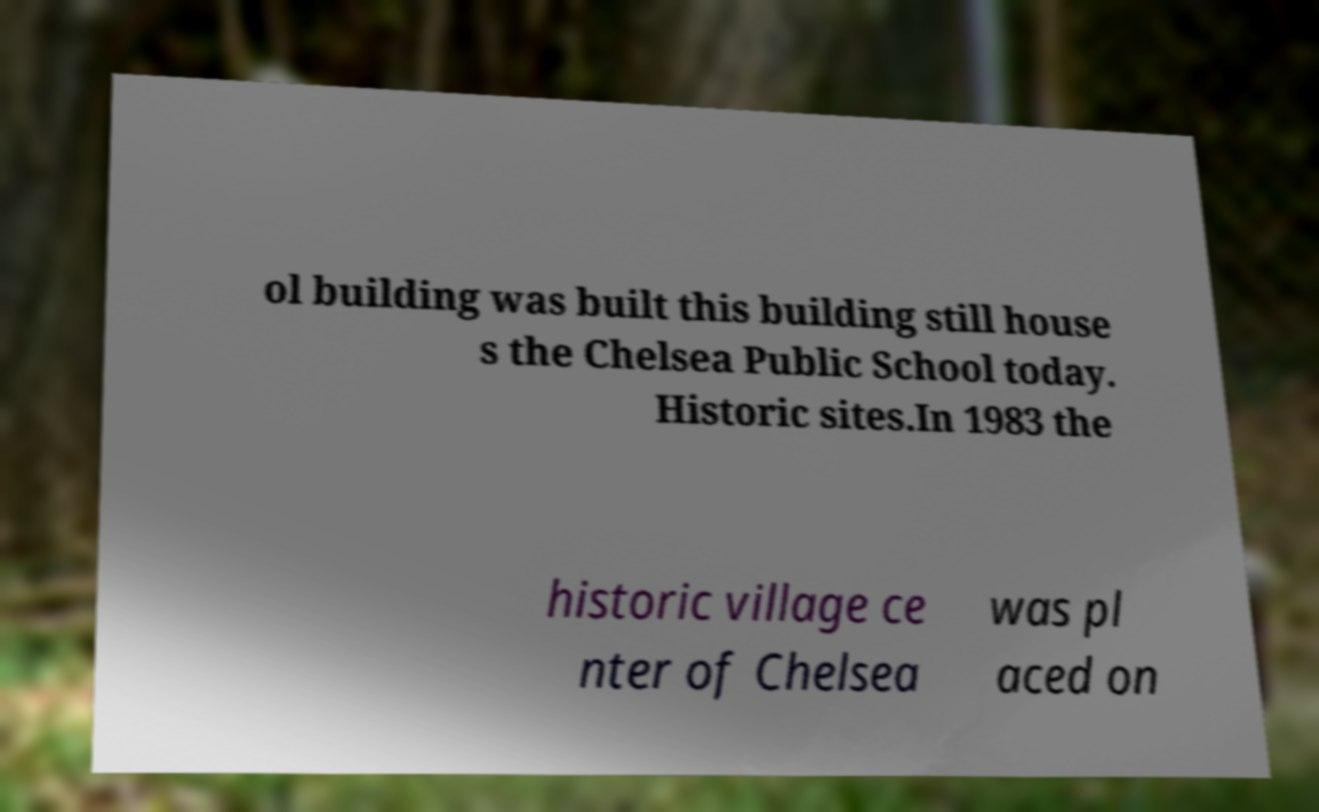Please identify and transcribe the text found in this image. ol building was built this building still house s the Chelsea Public School today. Historic sites.In 1983 the historic village ce nter of Chelsea was pl aced on 